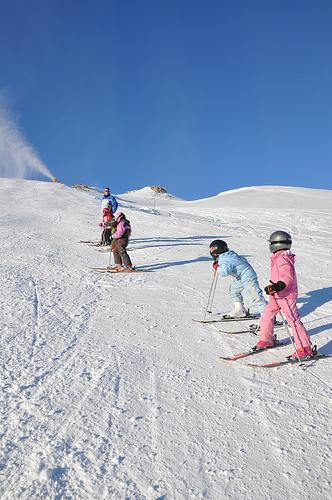For the visual entailment task, are there multiple people participating in a snow activity in this image? Yes, there are multiple skiers participating in a snow activity. Based on the information given, what can you infer about the gender of the two skiers wearing colorful snowsuits? The two skiers are likely a boy, wearing a blue snowsuit, and a girl, wearing a pink snowsuit. What color is the helmet worn by the skier in pink snow pants and jacket? Gray. Write a brief advertisement highlighting the colorful snowsuits in this image. Elevate your skiing experience with our vibrant, eye-catching snowsuits! Stay warm and be the center of attention as you glide down the mountain in our pink and blue outfits - perfect for fun-loving skiers. Please describe a visible element from the background of the image. White clouds in a blue sky can be seen in various parts of the background. Mention an aspect of weather that appears in the image. Snow blowing against the sky is present, indicating a windy or snowy day. Identify the primary activity taking place on this snowy mountain. Skiing, with several skiers wearing colorful snowsuits. In a multi-choice VQA task, which of the following items can be found in the image: white clouds, dark clouds, rainbows, snow-capped trees? White clouds and snow-capped trees. Describe the interaction between the skier in the pink snowsuit and the skier in the blue snowsuit, based on their positions in the image. The skier wearing a pink snowsuit is situated next to the skier wearing a blue snowsuit, indicating that they may be skiing together or in close proximity on the mountain. 